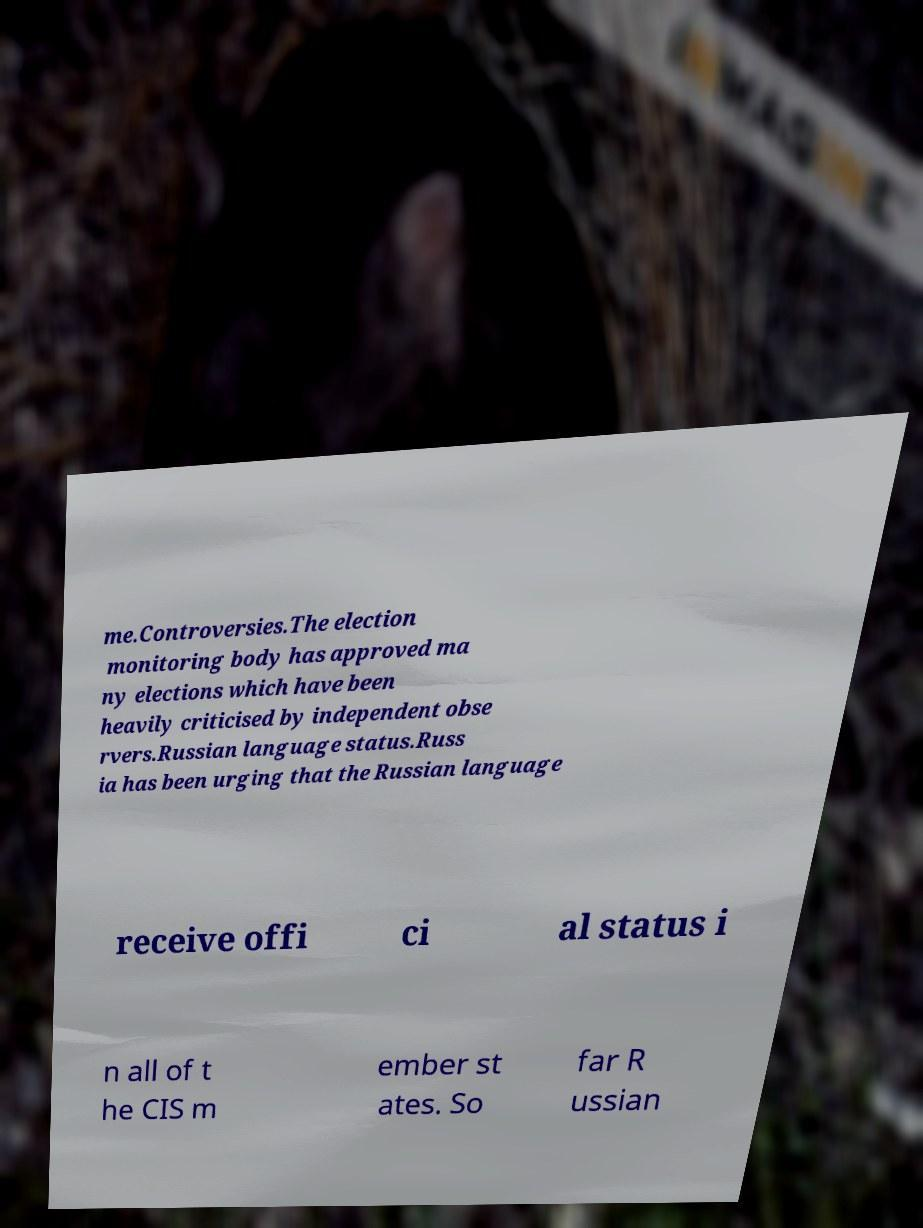Can you read and provide the text displayed in the image?This photo seems to have some interesting text. Can you extract and type it out for me? me.Controversies.The election monitoring body has approved ma ny elections which have been heavily criticised by independent obse rvers.Russian language status.Russ ia has been urging that the Russian language receive offi ci al status i n all of t he CIS m ember st ates. So far R ussian 